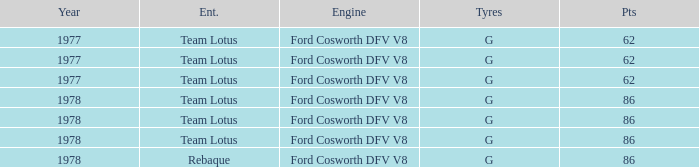Help me parse the entirety of this table. {'header': ['Year', 'Ent.', 'Engine', 'Tyres', 'Pts'], 'rows': [['1977', 'Team Lotus', 'Ford Cosworth DFV V8', 'G', '62'], ['1977', 'Team Lotus', 'Ford Cosworth DFV V8', 'G', '62'], ['1977', 'Team Lotus', 'Ford Cosworth DFV V8', 'G', '62'], ['1978', 'Team Lotus', 'Ford Cosworth DFV V8', 'G', '86'], ['1978', 'Team Lotus', 'Ford Cosworth DFV V8', 'G', '86'], ['1978', 'Team Lotus', 'Ford Cosworth DFV V8', 'G', '86'], ['1978', 'Rebaque', 'Ford Cosworth DFV V8', 'G', '86']]} What is the Motor that has a Focuses bigger than 62, and a Participant of rebaque? Ford Cosworth DFV V8. 